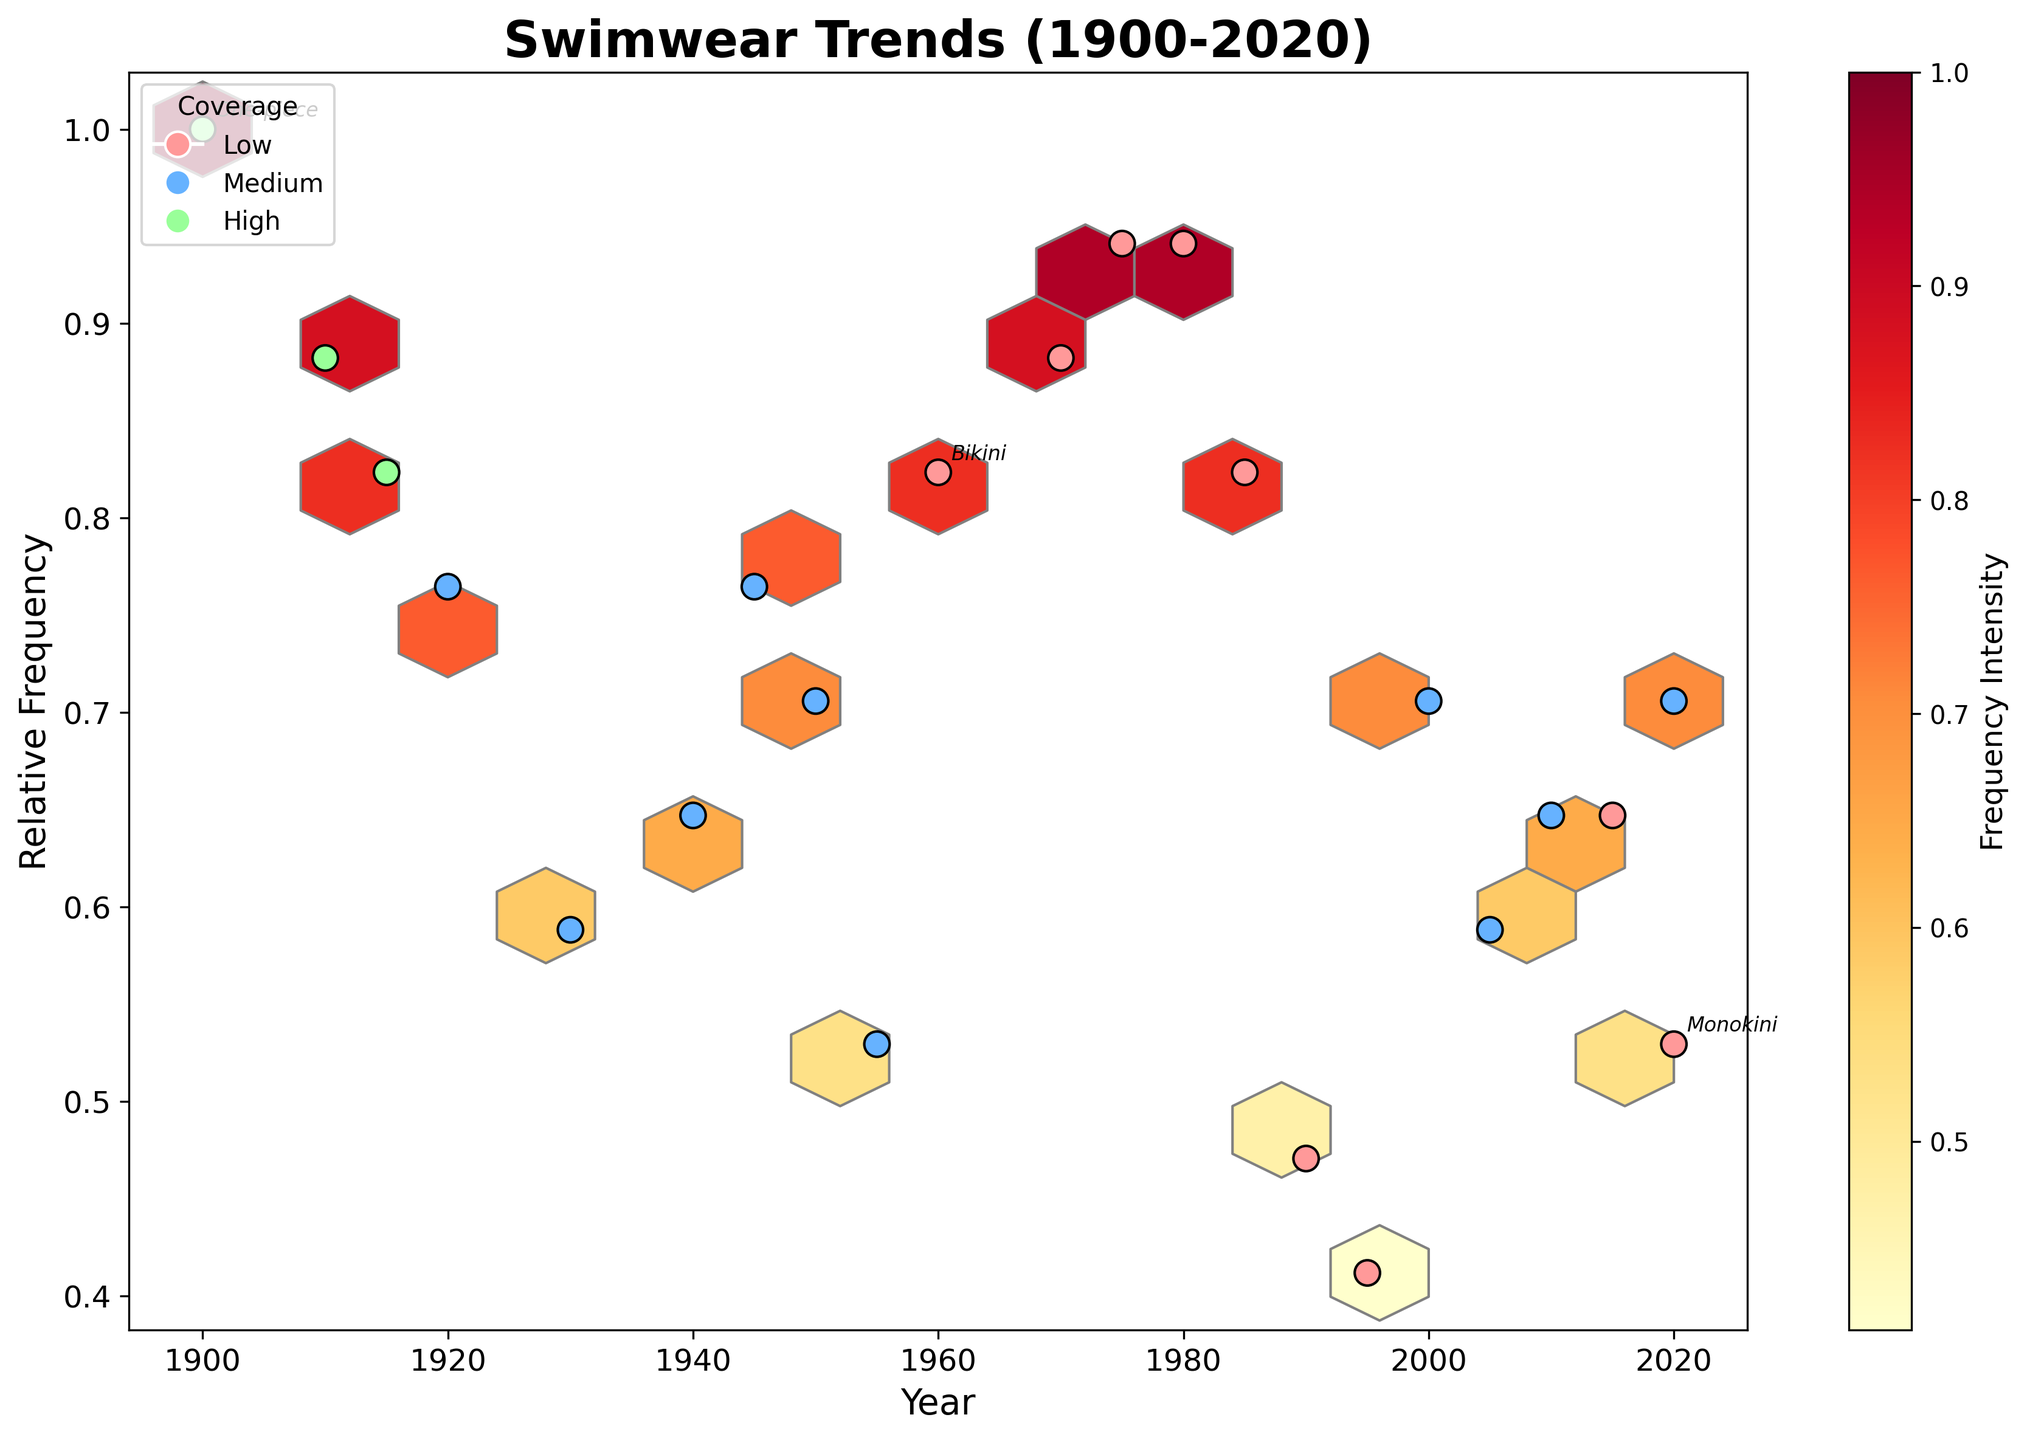What is the title of the hexbin plot? The title is displayed at the top of the plot. By visually reading the text at the top, we see 'Swimwear Trends (1900-2020)'.
Answer: Swimwear Trends (1900-2020) What does the x-axis represent? The x-axis label is typically positioned below the axis line. It reads 'Year', indicating that the x-axis represents the years from 1900 to 2020.
Answer: Year How many distinct coverage categories are represented by different colors in the scatter plot overlay? The legend on the plot shows three different colors, each corresponding to a coverage category: 'High', 'Medium', and 'Low'.
Answer: 3 Which coverage category has a red color? The legend, positioned in the upper left, indicates 'Low' coverage is represented by the red color.
Answer: Low What is the frequency intensity color indicated by the colorbar? The colorbar, placed adjacent to the plot, is labeled 'Frequency Intensity', and its gradient from light yellow to red indicates increasing frequency intensity.
Answer: Yellow to Red What swimwear style appeared around 1940 with medium coverage? By looking at the scatter points around 1940 on the plot, we can find annotated or labeled swimwear styles such as 'Skirted' with medium coverage.
Answer: Skirted Which year corresponds to the highest relative frequency point for low coverage swimwear? By examining the scatter plot, we see that the highest positioned point within the red 'Low' coverage color appears around 1980.
Answer: 1980 Compare the relative frequency of 'Bikini' (1960) to 'Monokini' (2020). Which is higher? Checking the plot for 'Bikini' in 1960 and 'Monokini' in 2020, we observe that 'Bikini' (normalized frequency around 0.82) has a higher relative frequency than 'Monokini' (around 0.53).
Answer: Bikini How does the frequency trend of medium coverage swimwear change from 1910 to 2020? Observing the color-coded scatter points from 1910 to 2020: 'Medium' coverage points range, showing varying frequencies, but generally trending downward towards 2015-2020.
Answer: Downward Which swimwear style has been annotated on the plot for the year 1975? By finding the annotation on the plot around the year 1975, the text indicates the 'Triangle top' style.
Answer: Triangle top 